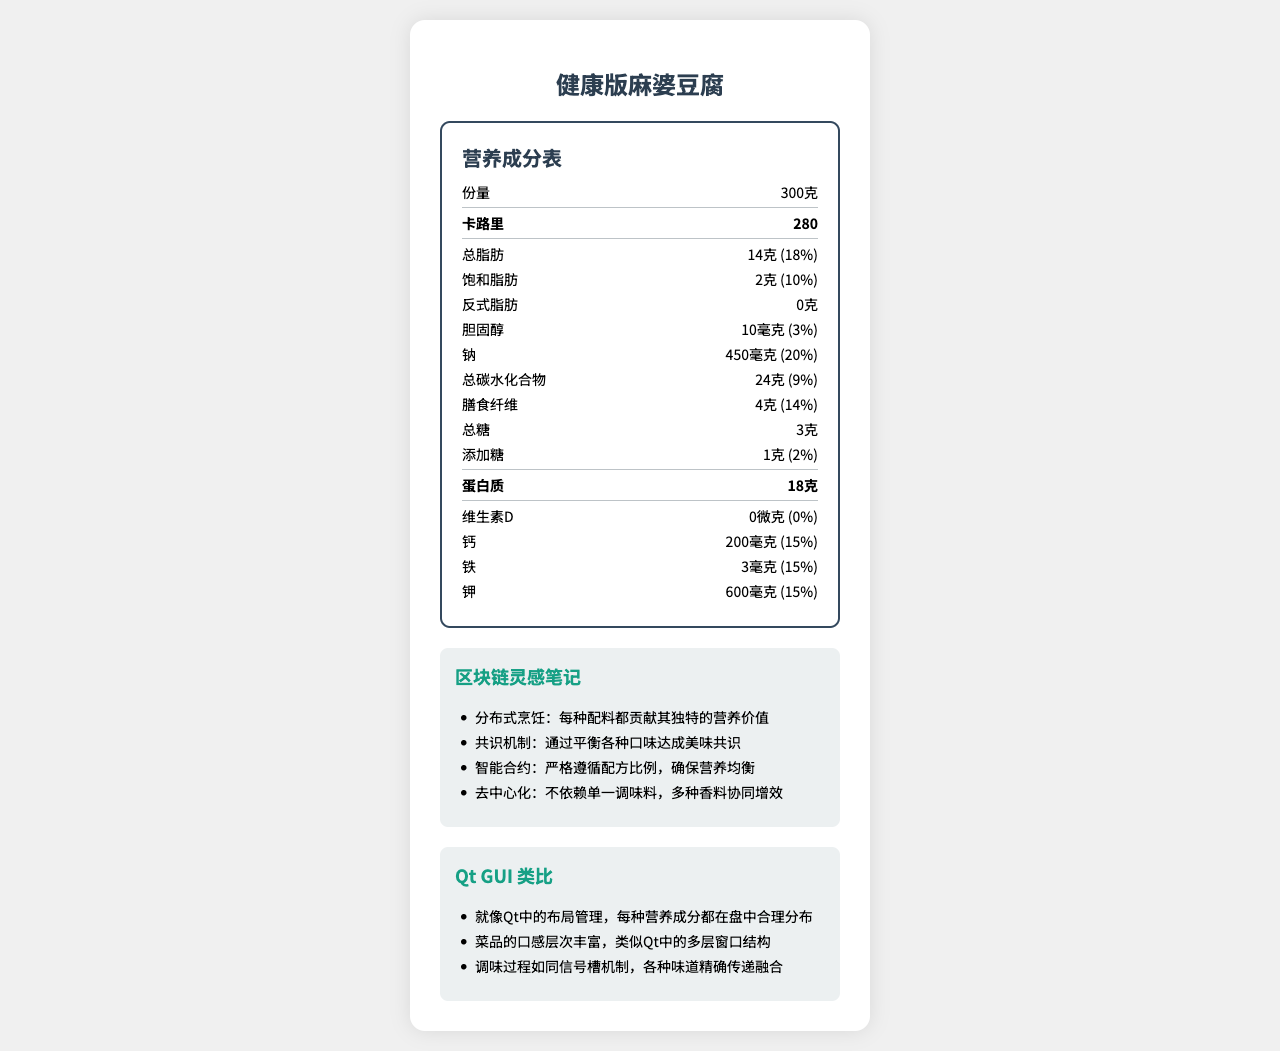what is the serving size of 健康版麻婆豆腐? The serving size is clearly listed as "300克" in the nutrition label.
Answer: 300克 how many calories are in a serving of 健康版麻婆豆腐? The calories per serving are prominently displayed as 280 in the nutrition label.
Answer: 280 what is the total fat content and its daily value percentage? The total fat content is listed as 14克, and the daily value percentage is shown as 18%.
Answer: 14克, 18% is there any trans fat in 健康版麻婆豆腐? The document states "0克" for trans fat, indicating there is no trans fat in the dish.
Answer: No how much protein does a serving contain? The amount of protein is listed as 18克 in the nutrition label.
Answer: 18克 which of the following is not one of the main ingredients? A. 杏鲍菇 (King Oyster Mushroom) B. 豆瓣酱 (Doubanjiang) C. 瘦猪肉 (Lean Pork) D. 花椒 (Sichuan Peppercorn) 杏鲍菇 is mentioned in the health adaptations section but not in the main ingredients list.
Answer: A. 杏鲍菇 (King Oyster Mushroom) what is the purpose of adding 杏鲍菇 to the dish? A. Increase the fat content B. Improve texture and nutrition C. Reduce protein content D. Increase sugar content The health adaptations section mentions that 杏鲍菇 is added to improve texture and nutrition.
Answer: B. Improve texture and nutrition does the dish use traditional cooking oil? The health adaptations section states that olive oil is used instead of traditional vegetable oil.
Answer: No does this dish contain enough vitamin D? The nutritional label shows that the amount of vitamin D is 0微克, which is 0% of the daily value.
Answer: No briefly summarize the main idea of the document. The document provides details on the nutritional content, health adaptations, benefits for tech professionals, and makes analogies to blockchain and Qt GUI concepts, offering a comprehensive view of the dish and its benefits.
Answer: The document presents the nutritional breakdown of 健康版麻婆豆腐, a health-conscious adaptation of a traditional Chinese dish. It emphasizes reduced fat, sodium, and increased protein and dietary fiber. It also includes insights relevant to tech professionals and analogies to blockchain and Qt GUI concepts. what is the main source of sodium in the dish? The document provides the amount of sodium but does not specify which ingredient is the main source of it.
Answer: Cannot be determined what mechanisms from blockchain technology are mentioned as an analogy? The blockchain-inspired notes list these mechanisms as analogies to the ingredients and preparation of the dish.
Answer: Distributed Cooking, Consensus Mechanism, Smart Contract, Decentralization how does this dish help alleviate issues related to prolonged sitting? The tech professional benefits section mentions that the dish is rich in dietary fiber, which helps improve digestive issues related to prolonged sitting.
Answer: Rich in dietary fiber 